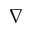<formula> <loc_0><loc_0><loc_500><loc_500>\nabla</formula> 